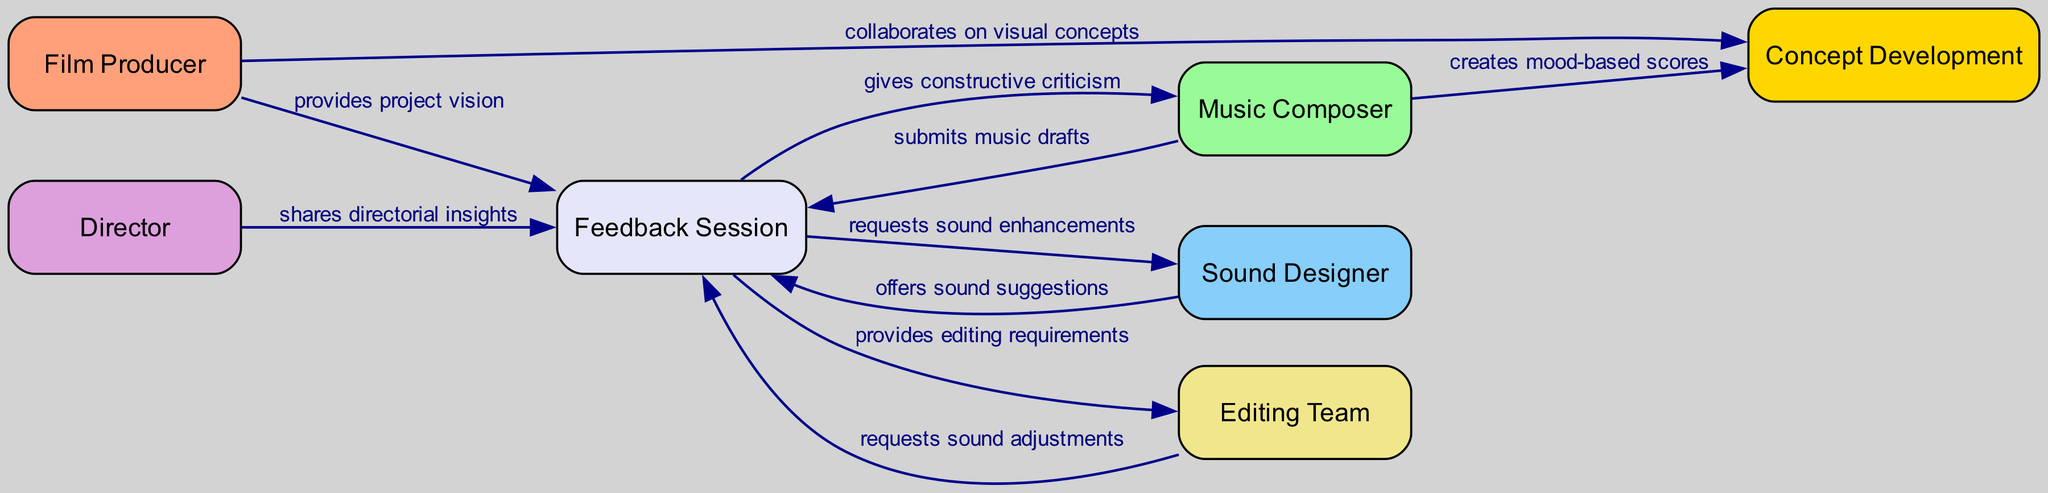What are the total number of nodes in the diagram? By counting the number of unique elements in the "nodes" section of the data provided, we find 7 nodes: Film Producer, Music Composer, Sound Designer, Director, Editing Team, Feedback Session, and Concept Development.
Answer: 7 Which node receives constructive criticism from the Feedback Session? The directed edge between "Feedback Session" and "Music Composer" with the label "gives constructive criticism" indicates that the Music Composer receives constructive criticism during feedback.
Answer: Music Composer What is the relationship between the Film Producer and the Concept Development node? The edge from "Film Producer" to "Concept Development" states that the Film Producer collaborates on visual concepts, indicating a direct relationship where the Film Producer influences Concept Development.
Answer: collaborates on visual concepts How many edges are connected to the Feedback Session node? By examining the edges directed to and from the Feedback Session node, we identify 5 outgoing edges: to Music Composer, Sound Designer, Editing Team, and 4 incoming edges from Film Producer, Music Composer, Sound Designer, Director, and Editing Team. This totals to 5 edges connected to the Feedback Session node.
Answer: 5 Which node submits music drafts and how many times does it connect with the Feedback Session? The node "Music Composer" submits music drafts to the Feedback Session, as denoted by the directed edge labeled "submits music drafts." It connects once with the Feedback Session.
Answer: Music Composer What does the Sound Designer offer during the Feedback Session? According to the edge labeled "offers sound suggestions," the Sound Designer contributes by providing sound suggestions within the context of the Feedback Session.
Answer: offers sound suggestions Which node is linked directly to the Director and what is the nature of their connection? The "Director" node is directly linked to the "Feedback Session" node through the edge labeled "shares directorial insights," suggesting that the Director provides input regarding direction during feedback.
Answer: shares directorial insights What collaborative action does the Music Composer take regarding the Concept Development? The Music Composer engages in the action of creating mood-based scores, as indicated by the directed edge from the Music Composer to the Concept Development node.
Answer: creates mood-based scores 